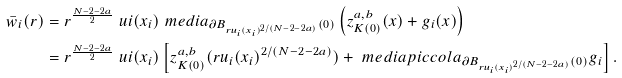<formula> <loc_0><loc_0><loc_500><loc_500>\bar { w } _ { i } ( r ) & = r ^ { \frac { N - 2 - 2 a } 2 } \ u i ( x _ { i } ) \ m e d i a _ { \partial B _ { r u _ { i } ( x _ { i } ) ^ { 2 / ( N - 2 - 2 a ) } } ( 0 ) } \left ( z _ { K ( 0 ) } ^ { a , b } ( x ) + g _ { i } ( x ) \right ) \\ & = r ^ { \frac { N - 2 - 2 a } 2 } \ u i ( x _ { i } ) \left [ z _ { K ( 0 ) } ^ { a , b } ( r u _ { i } ( x _ { i } ) ^ { 2 / ( N - 2 - 2 a ) } ) + { \ m e d i a p i c c o l a _ { \partial B _ { r u _ { i } ( x _ { i } ) ^ { 2 / ( N - 2 - 2 a ) } } ( 0 ) } g _ { i } } \right ] .</formula> 